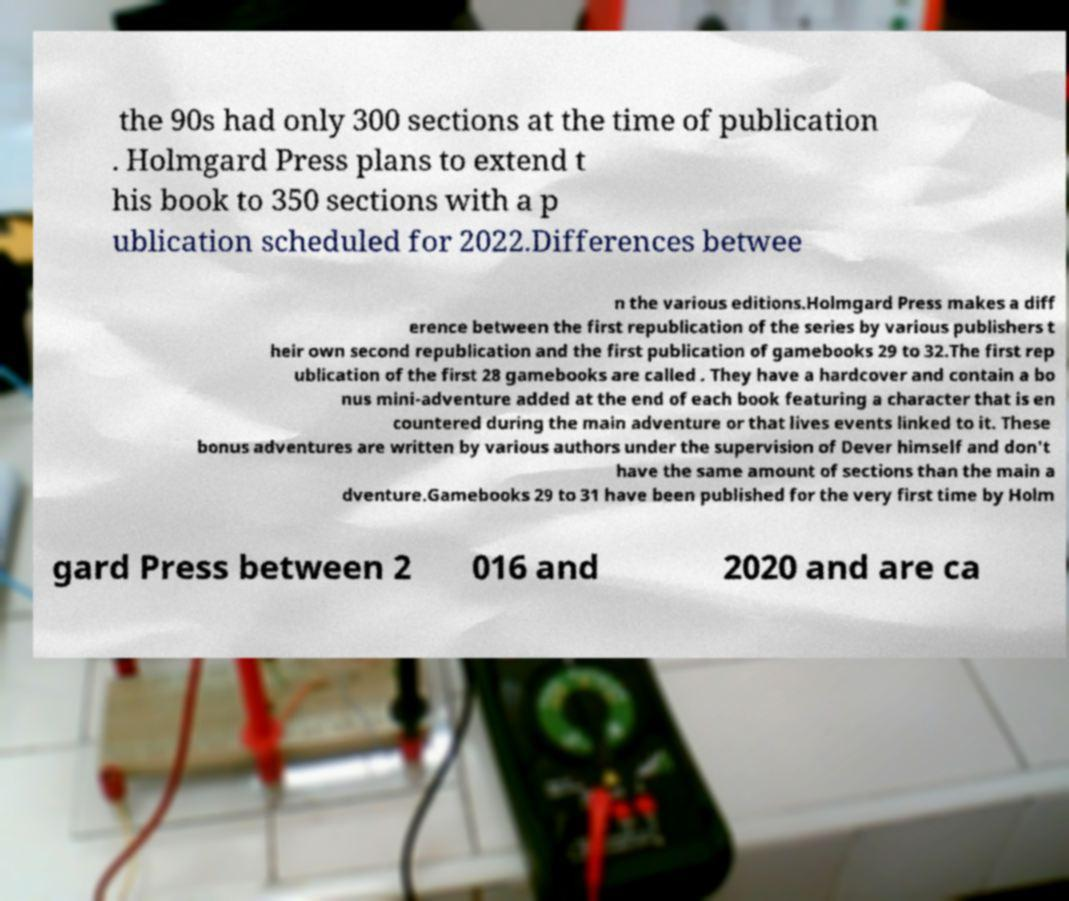Could you extract and type out the text from this image? the 90s had only 300 sections at the time of publication . Holmgard Press plans to extend t his book to 350 sections with a p ublication scheduled for 2022.Differences betwee n the various editions.Holmgard Press makes a diff erence between the first republication of the series by various publishers t heir own second republication and the first publication of gamebooks 29 to 32.The first rep ublication of the first 28 gamebooks are called . They have a hardcover and contain a bo nus mini-adventure added at the end of each book featuring a character that is en countered during the main adventure or that lives events linked to it. These bonus adventures are written by various authors under the supervision of Dever himself and don't have the same amount of sections than the main a dventure.Gamebooks 29 to 31 have been published for the very first time by Holm gard Press between 2 016 and 2020 and are ca 